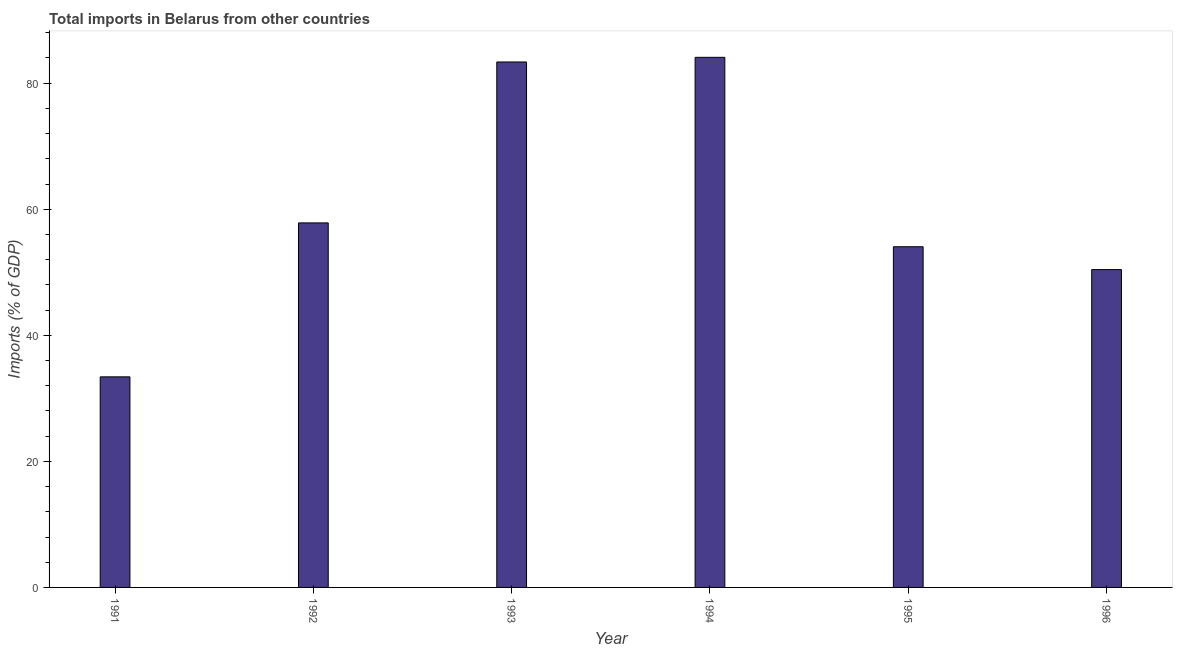Does the graph contain grids?
Ensure brevity in your answer.  No. What is the title of the graph?
Your answer should be compact. Total imports in Belarus from other countries. What is the label or title of the Y-axis?
Keep it short and to the point. Imports (% of GDP). What is the total imports in 1993?
Your answer should be very brief. 83.37. Across all years, what is the maximum total imports?
Provide a succinct answer. 84.1. Across all years, what is the minimum total imports?
Your answer should be very brief. 33.41. What is the sum of the total imports?
Your answer should be compact. 363.2. What is the difference between the total imports in 1991 and 1996?
Give a very brief answer. -17.02. What is the average total imports per year?
Offer a very short reply. 60.53. What is the median total imports?
Your response must be concise. 55.95. In how many years, is the total imports greater than 8 %?
Provide a short and direct response. 6. What is the ratio of the total imports in 1992 to that in 1993?
Provide a succinct answer. 0.69. What is the difference between the highest and the second highest total imports?
Your response must be concise. 0.74. What is the difference between the highest and the lowest total imports?
Offer a terse response. 50.69. In how many years, is the total imports greater than the average total imports taken over all years?
Make the answer very short. 2. What is the Imports (% of GDP) in 1991?
Give a very brief answer. 33.41. What is the Imports (% of GDP) of 1992?
Give a very brief answer. 57.84. What is the Imports (% of GDP) of 1993?
Give a very brief answer. 83.37. What is the Imports (% of GDP) in 1994?
Your answer should be very brief. 84.1. What is the Imports (% of GDP) in 1995?
Provide a short and direct response. 54.05. What is the Imports (% of GDP) of 1996?
Keep it short and to the point. 50.42. What is the difference between the Imports (% of GDP) in 1991 and 1992?
Your response must be concise. -24.43. What is the difference between the Imports (% of GDP) in 1991 and 1993?
Your response must be concise. -49.96. What is the difference between the Imports (% of GDP) in 1991 and 1994?
Make the answer very short. -50.69. What is the difference between the Imports (% of GDP) in 1991 and 1995?
Provide a succinct answer. -20.64. What is the difference between the Imports (% of GDP) in 1991 and 1996?
Your response must be concise. -17.02. What is the difference between the Imports (% of GDP) in 1992 and 1993?
Give a very brief answer. -25.53. What is the difference between the Imports (% of GDP) in 1992 and 1994?
Ensure brevity in your answer.  -26.27. What is the difference between the Imports (% of GDP) in 1992 and 1995?
Keep it short and to the point. 3.78. What is the difference between the Imports (% of GDP) in 1992 and 1996?
Your answer should be compact. 7.41. What is the difference between the Imports (% of GDP) in 1993 and 1994?
Keep it short and to the point. -0.74. What is the difference between the Imports (% of GDP) in 1993 and 1995?
Provide a succinct answer. 29.31. What is the difference between the Imports (% of GDP) in 1993 and 1996?
Your answer should be very brief. 32.94. What is the difference between the Imports (% of GDP) in 1994 and 1995?
Provide a succinct answer. 30.05. What is the difference between the Imports (% of GDP) in 1994 and 1996?
Provide a short and direct response. 33.68. What is the difference between the Imports (% of GDP) in 1995 and 1996?
Provide a succinct answer. 3.63. What is the ratio of the Imports (% of GDP) in 1991 to that in 1992?
Ensure brevity in your answer.  0.58. What is the ratio of the Imports (% of GDP) in 1991 to that in 1993?
Your response must be concise. 0.4. What is the ratio of the Imports (% of GDP) in 1991 to that in 1994?
Your response must be concise. 0.4. What is the ratio of the Imports (% of GDP) in 1991 to that in 1995?
Give a very brief answer. 0.62. What is the ratio of the Imports (% of GDP) in 1991 to that in 1996?
Your response must be concise. 0.66. What is the ratio of the Imports (% of GDP) in 1992 to that in 1993?
Offer a very short reply. 0.69. What is the ratio of the Imports (% of GDP) in 1992 to that in 1994?
Your answer should be very brief. 0.69. What is the ratio of the Imports (% of GDP) in 1992 to that in 1995?
Offer a very short reply. 1.07. What is the ratio of the Imports (% of GDP) in 1992 to that in 1996?
Make the answer very short. 1.15. What is the ratio of the Imports (% of GDP) in 1993 to that in 1994?
Give a very brief answer. 0.99. What is the ratio of the Imports (% of GDP) in 1993 to that in 1995?
Provide a succinct answer. 1.54. What is the ratio of the Imports (% of GDP) in 1993 to that in 1996?
Keep it short and to the point. 1.65. What is the ratio of the Imports (% of GDP) in 1994 to that in 1995?
Your answer should be very brief. 1.56. What is the ratio of the Imports (% of GDP) in 1994 to that in 1996?
Your answer should be compact. 1.67. What is the ratio of the Imports (% of GDP) in 1995 to that in 1996?
Make the answer very short. 1.07. 